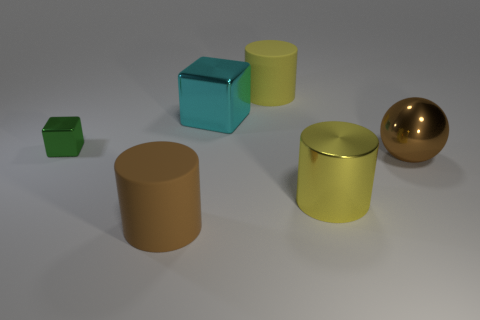Imagine these objects in a real-world setting. What kind of environment do you think they'd be found in? These objects could be part of a modern art installation, where their varying colors, shapes, and materials make them interesting pieces to contemplate. Alternatively, they might be found in a child's play area, serving as large geometric toys designed to teach about shapes and colors. 